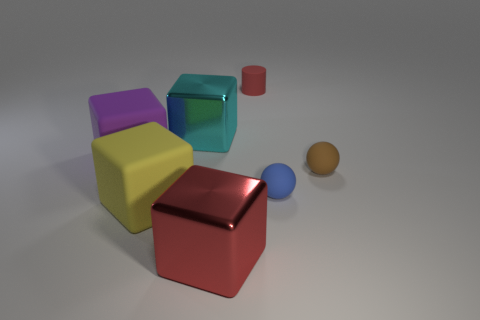Are the yellow thing and the red thing behind the big red metallic thing made of the same material?
Your answer should be very brief. Yes. What number of big gray rubber cylinders are there?
Give a very brief answer. 0. There is a matte thing behind the cyan thing; how big is it?
Your answer should be very brief. Small. How many purple cubes are the same size as the cyan metallic cube?
Offer a very short reply. 1. What is the material of the thing that is both on the left side of the cyan metal cube and in front of the blue ball?
Offer a very short reply. Rubber. There is a purple block that is the same size as the cyan object; what is it made of?
Ensure brevity in your answer.  Rubber. How big is the metallic thing that is to the left of the red metallic block that is in front of the rubber object in front of the blue rubber ball?
Make the answer very short. Large. There is a red cylinder that is the same material as the small blue object; what is its size?
Keep it short and to the point. Small. There is a yellow rubber thing; is it the same size as the metal cube left of the big red cube?
Offer a terse response. Yes. What is the shape of the red thing behind the large yellow matte block?
Your answer should be compact. Cylinder. 